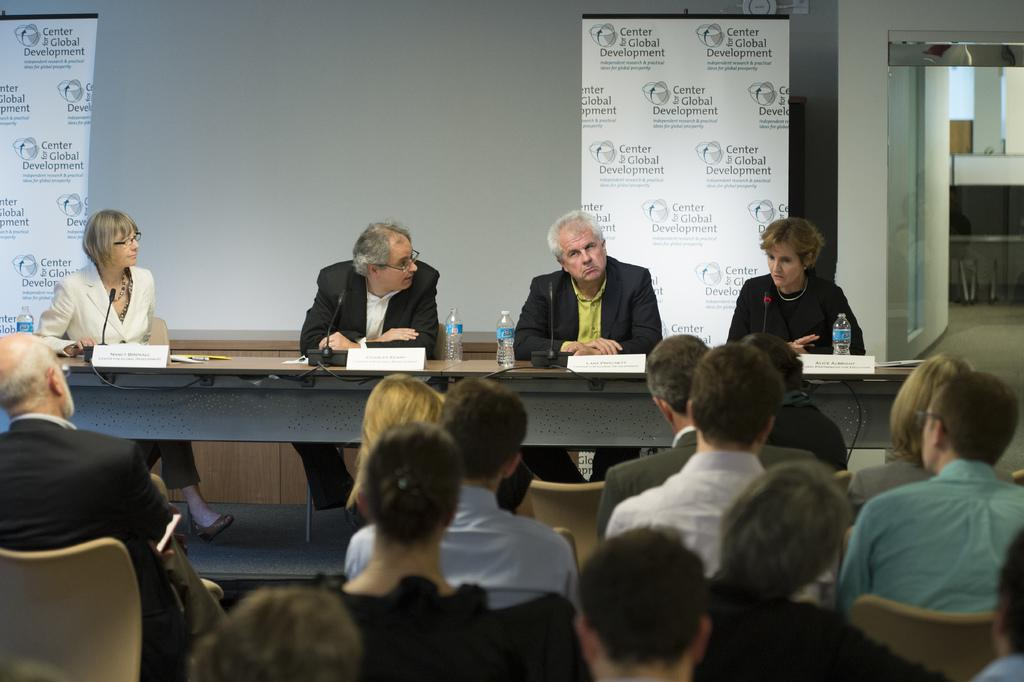How many people are sitting on the Dais in the image? There are four people sitting on the Dais in the image. What objects are in front of each person on the Dais? Each person has a microphone in front of them. Can you describe any other objects visible in the image? There is a water bottle visible in the image. Who might be present in the audience? The audience is present in the image, but their identities cannot be determined from the image alone. What can be seen in the background of the image? There is a banner in the background. Where is the cellar located in the image? There is no cellar present in the image. What suggestion does the banner in the background make? The banner in the background does not make any suggestions; it is simply a visual element in the image. 